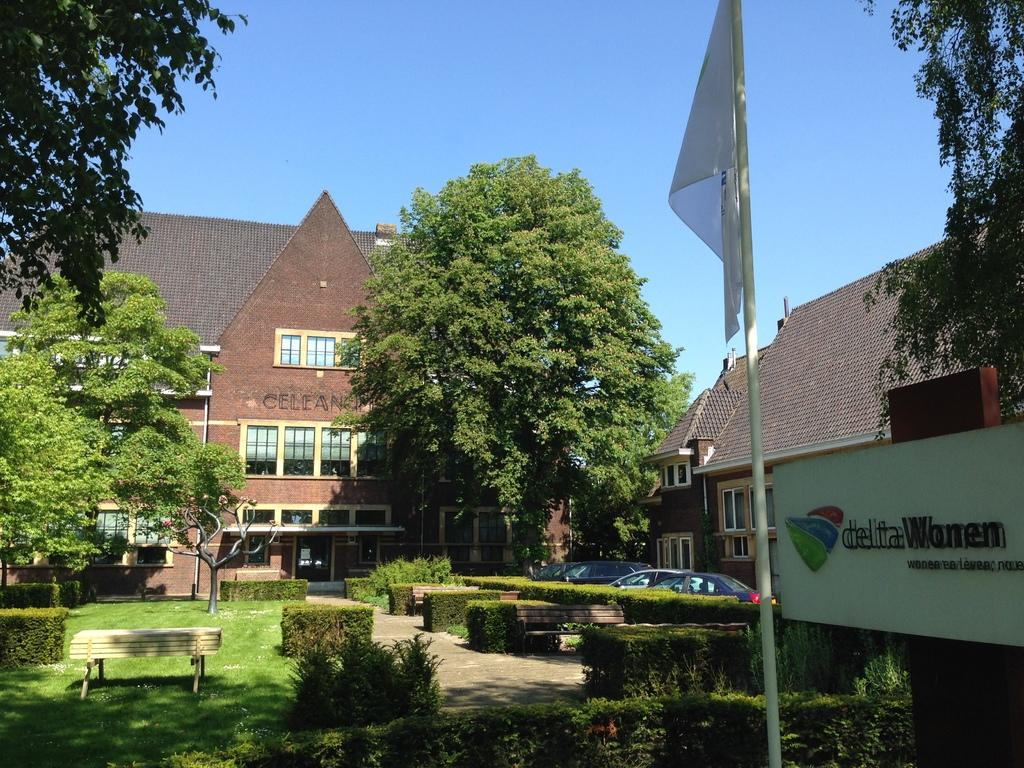What type of natural elements can be seen in the image? There are trees in the image. What type of seating is available in the image? There are benches in the image. What type of outdoor area is depicted in the image? There is a garden area in the image. What type of symbol is present in the image? There is a flag in the image. What type of transportation is visible in the image? There are vehicles parked in the image. What type of structures can be seen in the background of the image? There are houses in the background of the image. What is the condition of the sky in the background of the image? The sky is clear in the background of the image. Can you hear the bells ringing in the image? There are no bells present in the image, so it is not possible to hear them ringing. What type of cutting tool is being used in the garden area in the image? There is no cutting tool, such as scissors, present in the image. 